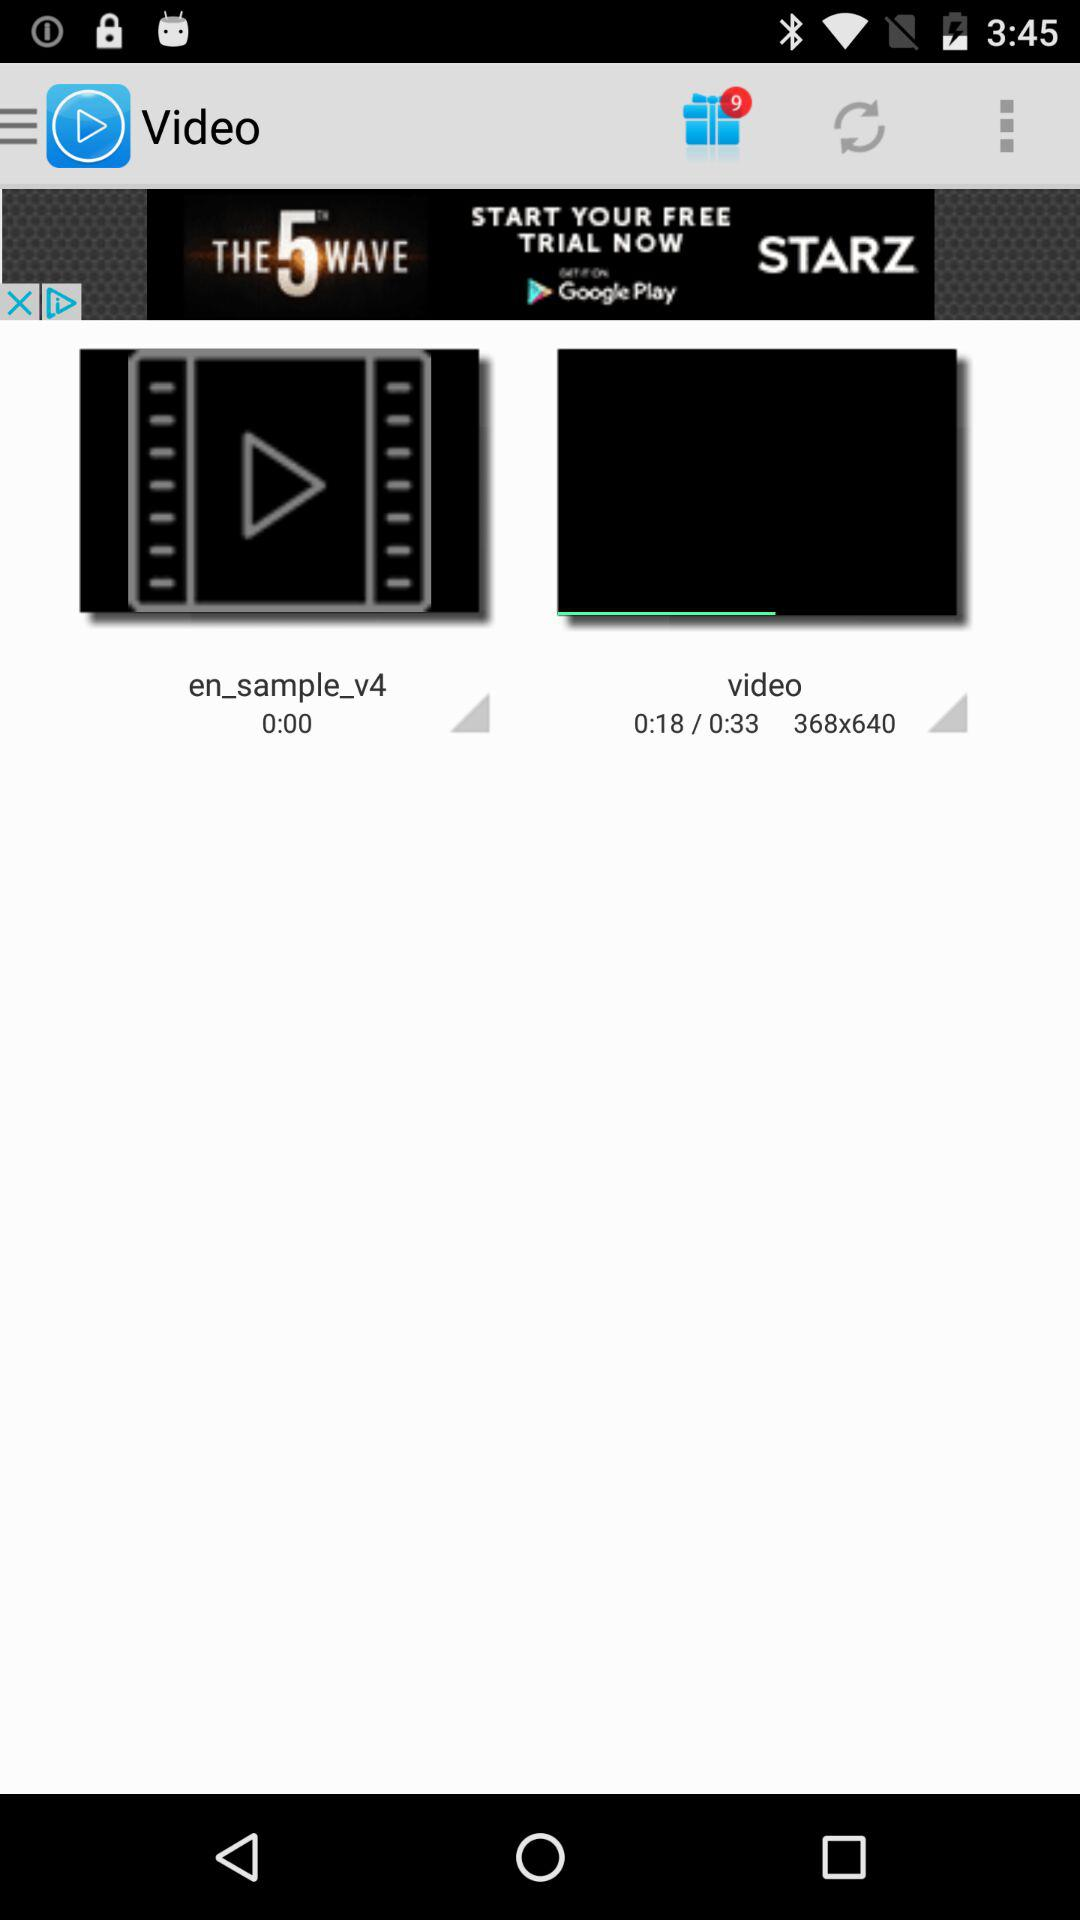How many more seconds has the second video been playing for than the first video?
Answer the question using a single word or phrase. 18 